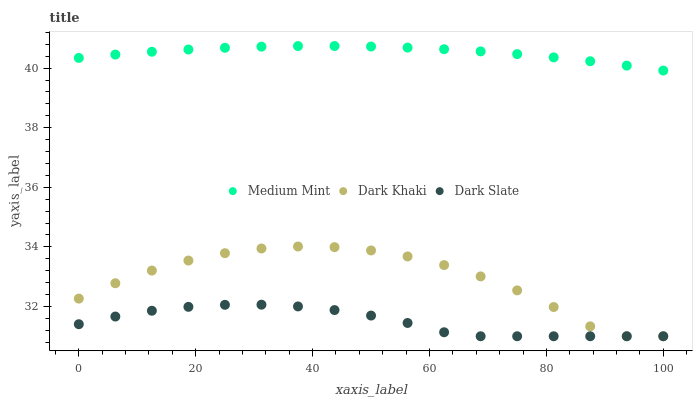Does Dark Slate have the minimum area under the curve?
Answer yes or no. Yes. Does Medium Mint have the maximum area under the curve?
Answer yes or no. Yes. Does Dark Khaki have the minimum area under the curve?
Answer yes or no. No. Does Dark Khaki have the maximum area under the curve?
Answer yes or no. No. Is Medium Mint the smoothest?
Answer yes or no. Yes. Is Dark Khaki the roughest?
Answer yes or no. Yes. Is Dark Slate the smoothest?
Answer yes or no. No. Is Dark Slate the roughest?
Answer yes or no. No. Does Dark Khaki have the lowest value?
Answer yes or no. Yes. Does Medium Mint have the highest value?
Answer yes or no. Yes. Does Dark Khaki have the highest value?
Answer yes or no. No. Is Dark Slate less than Medium Mint?
Answer yes or no. Yes. Is Medium Mint greater than Dark Khaki?
Answer yes or no. Yes. Does Dark Khaki intersect Dark Slate?
Answer yes or no. Yes. Is Dark Khaki less than Dark Slate?
Answer yes or no. No. Is Dark Khaki greater than Dark Slate?
Answer yes or no. No. Does Dark Slate intersect Medium Mint?
Answer yes or no. No. 